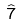Convert formula to latex. <formula><loc_0><loc_0><loc_500><loc_500>\hat { 7 }</formula> 